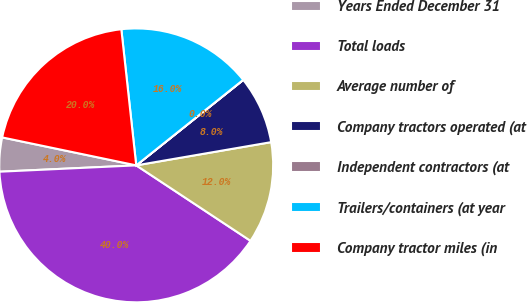<chart> <loc_0><loc_0><loc_500><loc_500><pie_chart><fcel>Years Ended December 31<fcel>Total loads<fcel>Average number of<fcel>Company tractors operated (at<fcel>Independent contractors (at<fcel>Trailers/containers (at year<fcel>Company tractor miles (in<nl><fcel>4.01%<fcel>39.97%<fcel>12.0%<fcel>8.01%<fcel>0.01%<fcel>16.0%<fcel>19.99%<nl></chart> 